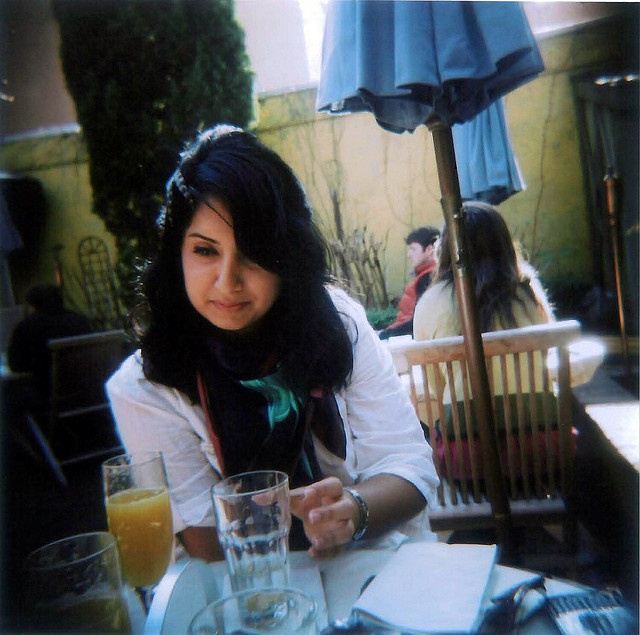Describe the objects in this image and their specific colors. I can see people in black, darkgray, and gray tones, dining table in black, gray, and lavender tones, umbrella in black, blue, and lightblue tones, chair in black, gray, tan, and darkgray tones, and people in black, gray, darkgray, and tan tones in this image. 